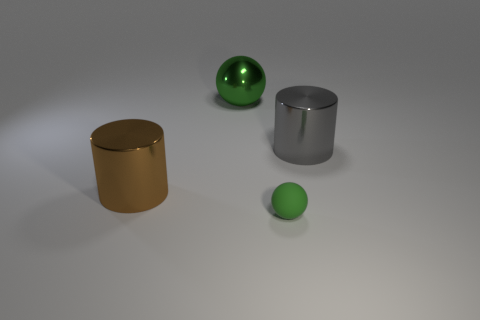Can you tell me the material of the objects presented in the image? Based on their appearances in the image, the objects seem to be made of various materials. The small green ball and the large shiny sphere appear to be of a reflective material; possibly glass or polished plastic, while the gold and silver cylinders look metallic, giving off the impression of being perhaps steel or aluminum with a brushed or matte surface finish. 